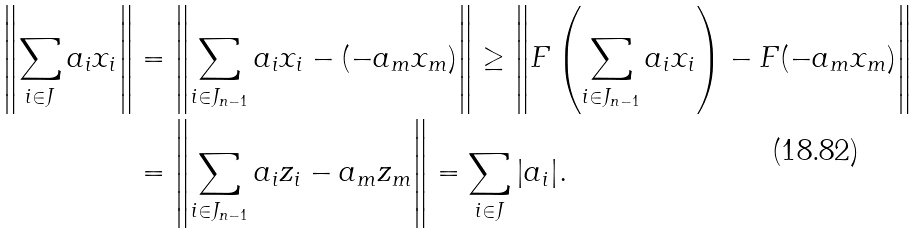Convert formula to latex. <formula><loc_0><loc_0><loc_500><loc_500>\left \| \sum _ { i \in J } { a _ { i } x _ { i } } \right \| & = \left \| \sum _ { i \in J _ { n - 1 } } { a _ { i } x _ { i } } - ( - a _ { m } x _ { m } ) \right \| \geq \left \| F \left ( \sum _ { i \in J _ { n - 1 } } { a _ { i } x _ { i } } \right ) - F ( - a _ { m } x _ { m } ) \right \| \\ & = \left \| \sum _ { i \in J _ { n - 1 } } a _ { i } z _ { i } - a _ { m } z _ { m } \right \| = \sum _ { i \in J } { | a _ { i } | } .</formula> 